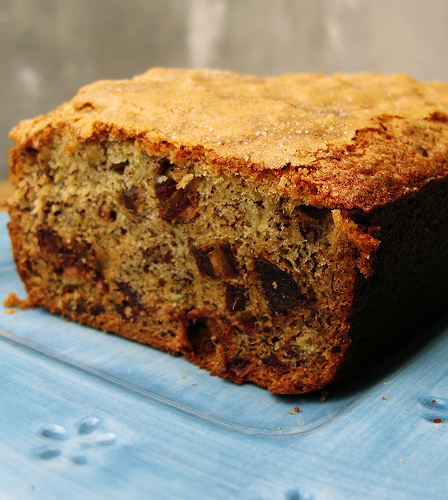<image>
Is the nut in the cake? Yes. The nut is contained within or inside the cake, showing a containment relationship. 